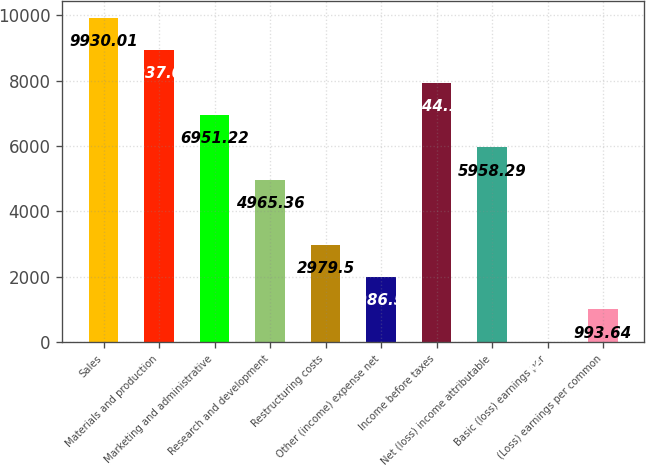Convert chart to OTSL. <chart><loc_0><loc_0><loc_500><loc_500><bar_chart><fcel>Sales<fcel>Materials and production<fcel>Marketing and administrative<fcel>Research and development<fcel>Restructuring costs<fcel>Other (income) expense net<fcel>Income before taxes<fcel>Net (loss) income attributable<fcel>Basic (loss) earnings per<fcel>(Loss) earnings per common<nl><fcel>9930.01<fcel>8937.08<fcel>6951.22<fcel>4965.36<fcel>2979.5<fcel>1986.57<fcel>7944.15<fcel>5958.29<fcel>0.71<fcel>993.64<nl></chart> 